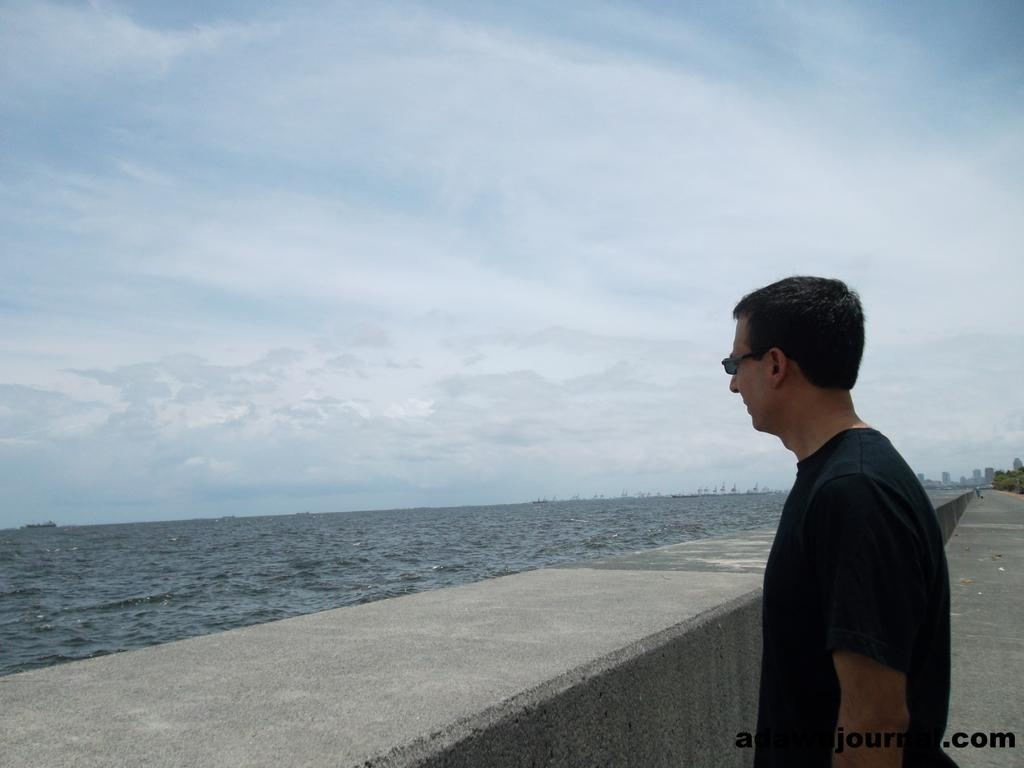Who is present in the image? There is a man in the image. What is the man's position in relation to the wall? The man is standing in front of a wall. What can be seen behind the wall? There is a water surface behind the wall. What type of prose is the man reading in the image? There is no indication in the image that the man is reading any prose. 